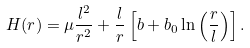<formula> <loc_0><loc_0><loc_500><loc_500>H ( r ) = \mu \frac { l ^ { 2 } } { r ^ { 2 } } + \frac { l } { r } \left [ b + b _ { 0 } \ln \left ( \frac { r } { l } \right ) \right ] .</formula> 